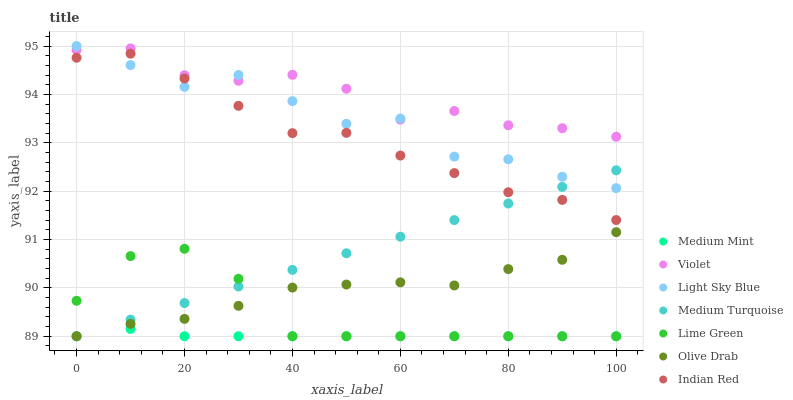Does Medium Mint have the minimum area under the curve?
Answer yes or no. Yes. Does Violet have the maximum area under the curve?
Answer yes or no. Yes. Does Indian Red have the minimum area under the curve?
Answer yes or no. No. Does Indian Red have the maximum area under the curve?
Answer yes or no. No. Is Medium Turquoise the smoothest?
Answer yes or no. Yes. Is Light Sky Blue the roughest?
Answer yes or no. Yes. Is Indian Red the smoothest?
Answer yes or no. No. Is Indian Red the roughest?
Answer yes or no. No. Does Medium Mint have the lowest value?
Answer yes or no. Yes. Does Indian Red have the lowest value?
Answer yes or no. No. Does Light Sky Blue have the highest value?
Answer yes or no. Yes. Does Indian Red have the highest value?
Answer yes or no. No. Is Lime Green less than Indian Red?
Answer yes or no. Yes. Is Indian Red greater than Medium Mint?
Answer yes or no. Yes. Does Light Sky Blue intersect Medium Turquoise?
Answer yes or no. Yes. Is Light Sky Blue less than Medium Turquoise?
Answer yes or no. No. Is Light Sky Blue greater than Medium Turquoise?
Answer yes or no. No. Does Lime Green intersect Indian Red?
Answer yes or no. No. 